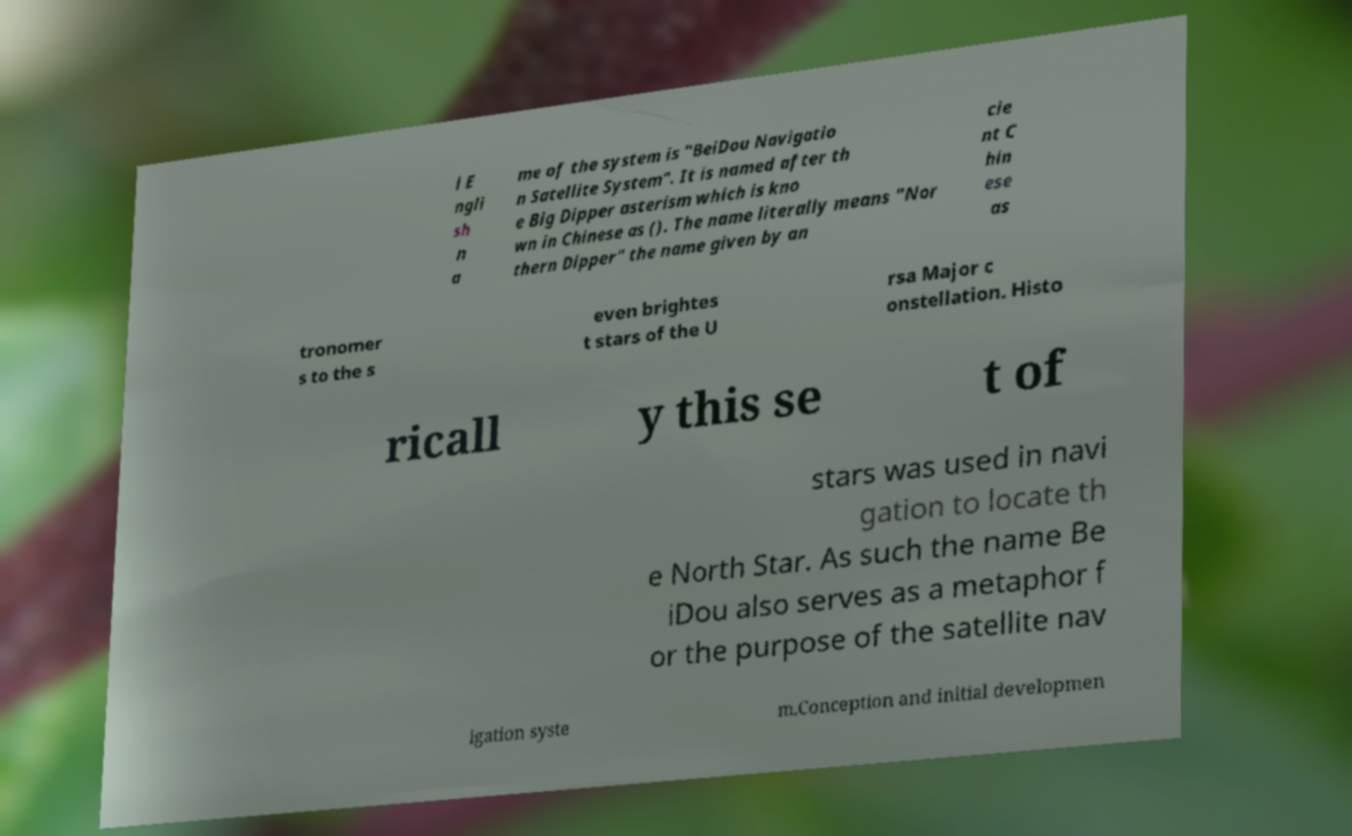Can you read and provide the text displayed in the image?This photo seems to have some interesting text. Can you extract and type it out for me? l E ngli sh n a me of the system is "BeiDou Navigatio n Satellite System". It is named after th e Big Dipper asterism which is kno wn in Chinese as (). The name literally means "Nor thern Dipper" the name given by an cie nt C hin ese as tronomer s to the s even brightes t stars of the U rsa Major c onstellation. Histo ricall y this se t of stars was used in navi gation to locate th e North Star. As such the name Be iDou also serves as a metaphor f or the purpose of the satellite nav igation syste m.Conception and initial developmen 